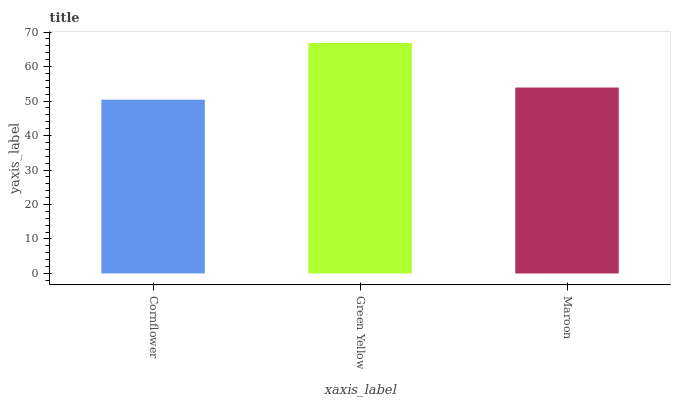Is Cornflower the minimum?
Answer yes or no. Yes. Is Green Yellow the maximum?
Answer yes or no. Yes. Is Maroon the minimum?
Answer yes or no. No. Is Maroon the maximum?
Answer yes or no. No. Is Green Yellow greater than Maroon?
Answer yes or no. Yes. Is Maroon less than Green Yellow?
Answer yes or no. Yes. Is Maroon greater than Green Yellow?
Answer yes or no. No. Is Green Yellow less than Maroon?
Answer yes or no. No. Is Maroon the high median?
Answer yes or no. Yes. Is Maroon the low median?
Answer yes or no. Yes. Is Green Yellow the high median?
Answer yes or no. No. Is Green Yellow the low median?
Answer yes or no. No. 